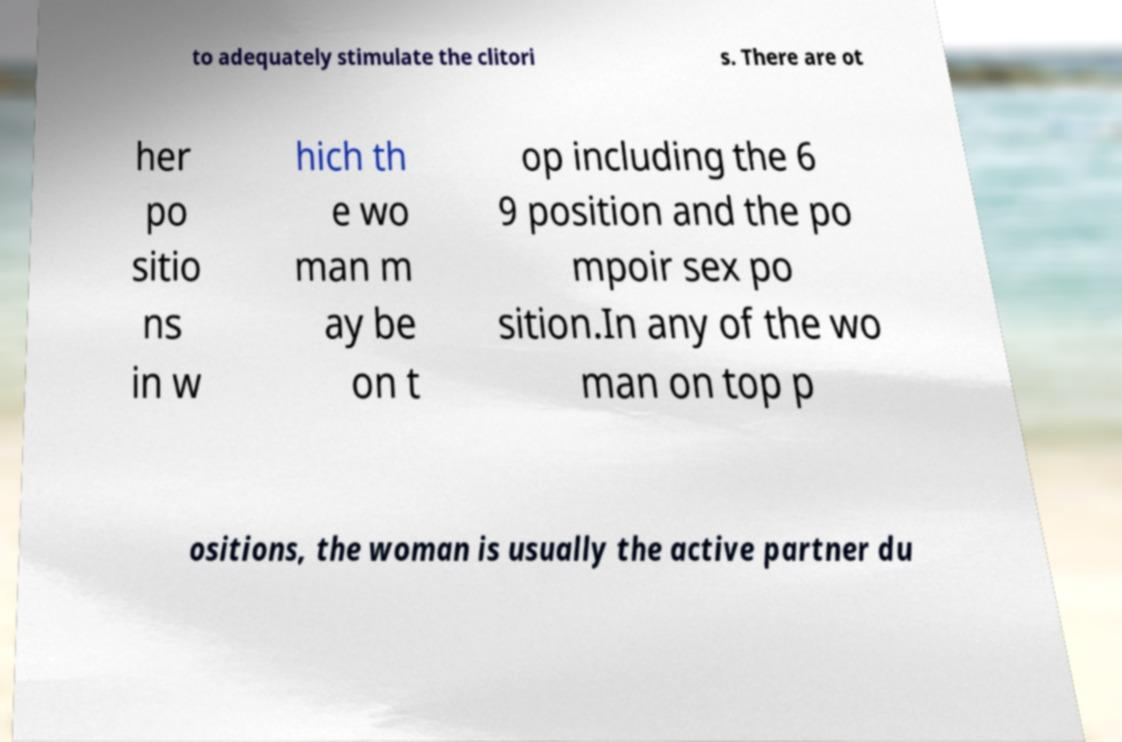Can you accurately transcribe the text from the provided image for me? to adequately stimulate the clitori s. There are ot her po sitio ns in w hich th e wo man m ay be on t op including the 6 9 position and the po mpoir sex po sition.In any of the wo man on top p ositions, the woman is usually the active partner du 